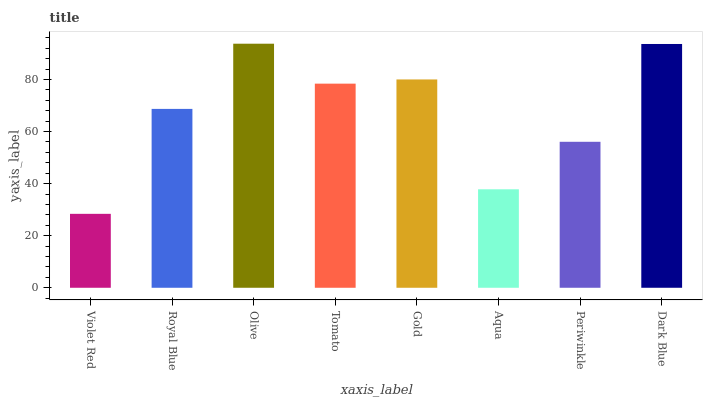Is Violet Red the minimum?
Answer yes or no. Yes. Is Olive the maximum?
Answer yes or no. Yes. Is Royal Blue the minimum?
Answer yes or no. No. Is Royal Blue the maximum?
Answer yes or no. No. Is Royal Blue greater than Violet Red?
Answer yes or no. Yes. Is Violet Red less than Royal Blue?
Answer yes or no. Yes. Is Violet Red greater than Royal Blue?
Answer yes or no. No. Is Royal Blue less than Violet Red?
Answer yes or no. No. Is Tomato the high median?
Answer yes or no. Yes. Is Royal Blue the low median?
Answer yes or no. Yes. Is Violet Red the high median?
Answer yes or no. No. Is Violet Red the low median?
Answer yes or no. No. 